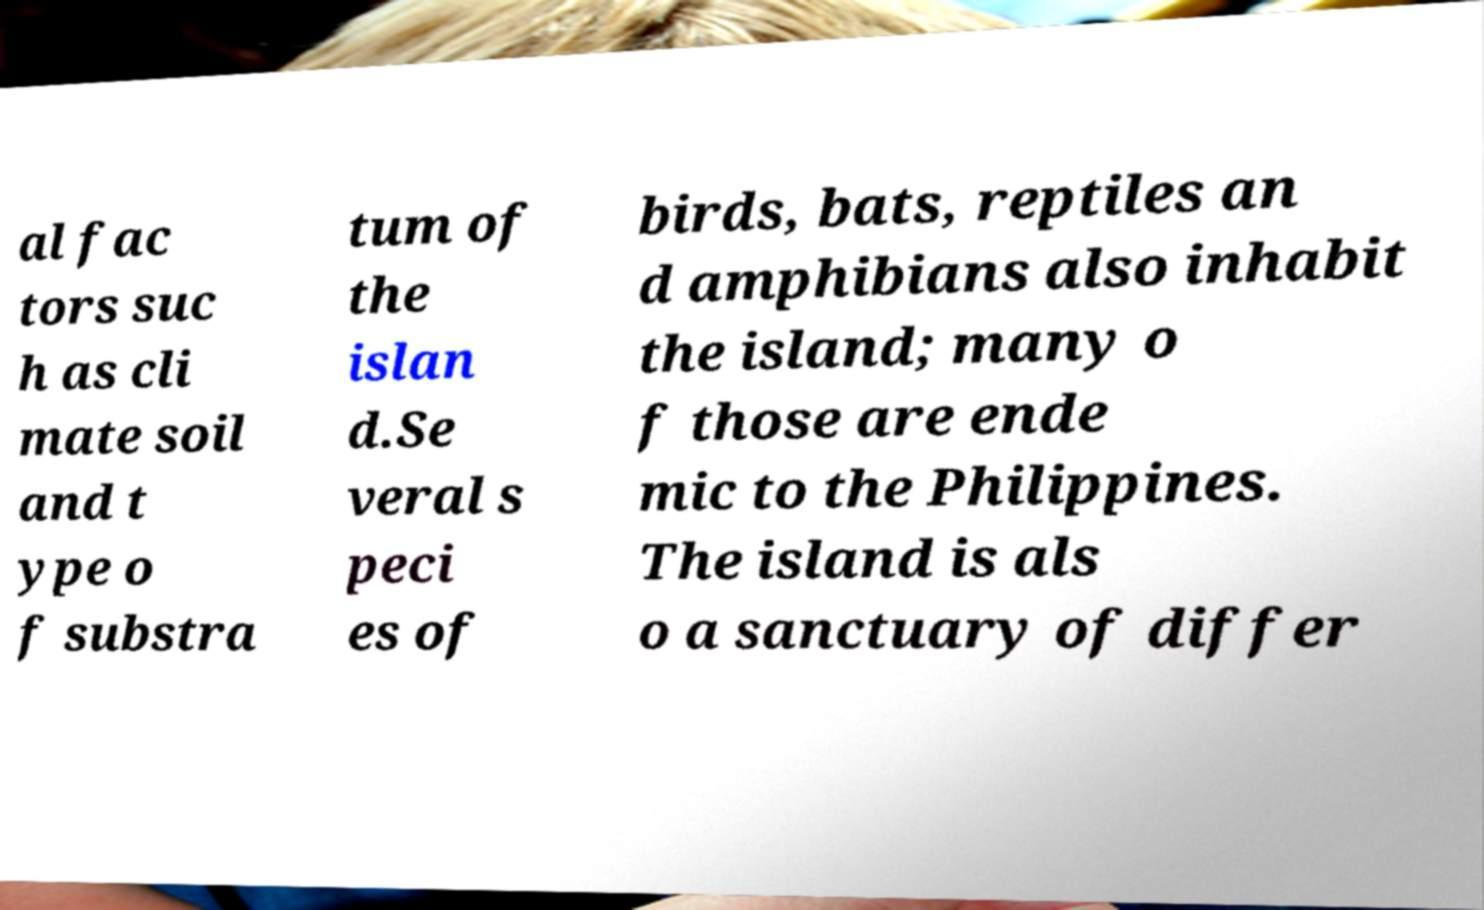Can you read and provide the text displayed in the image?This photo seems to have some interesting text. Can you extract and type it out for me? al fac tors suc h as cli mate soil and t ype o f substra tum of the islan d.Se veral s peci es of birds, bats, reptiles an d amphibians also inhabit the island; many o f those are ende mic to the Philippines. The island is als o a sanctuary of differ 